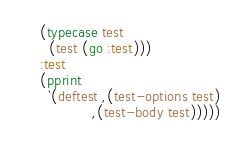<code> <loc_0><loc_0><loc_500><loc_500><_Lisp_>    (typecase test
      (test (go :test)))
    :test
    (pprint
      `(deftest ,(test-options test)
                ,(test-body test)))))
</code> 